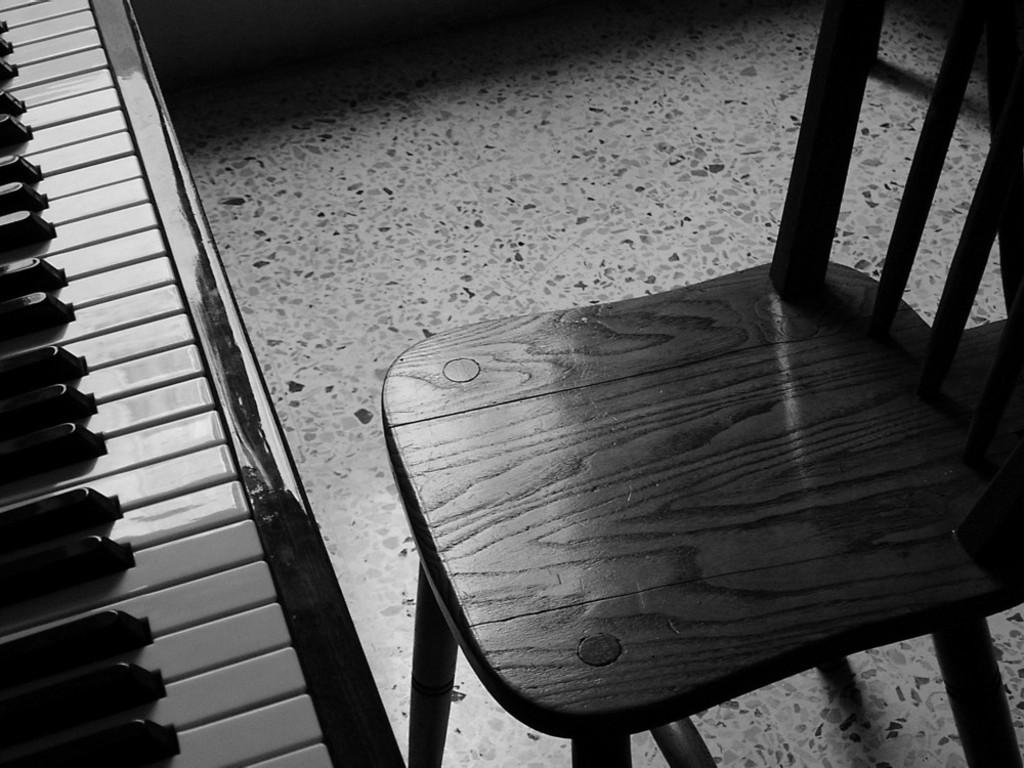What is placed on the floor in the image? There is a chair on the floor. What is in front of the chair? There is a keyboard with black and white keys in front of the chair. What type of animals can be seen at the zoo in the image? There is no zoo present in the image; it features a chair and a keyboard. How many beads are on the stage in the image? There is no stage or beads present in the image. 